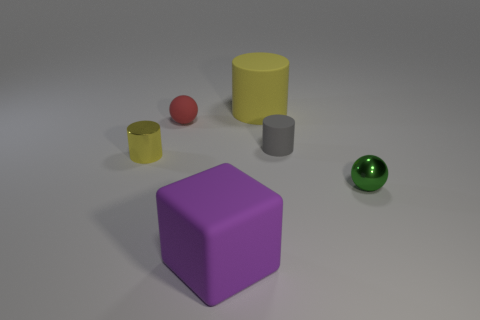How many other things are the same color as the metal cylinder?
Offer a very short reply. 1. Does the block have the same color as the big cylinder?
Your response must be concise. No. What number of yellow things have the same shape as the gray thing?
Provide a succinct answer. 2. Does the big purple thing have the same material as the red object?
Offer a terse response. Yes. What shape is the yellow metal thing behind the object that is in front of the shiny sphere?
Offer a very short reply. Cylinder. What number of purple things are to the left of the yellow cylinder that is behind the small rubber cylinder?
Provide a short and direct response. 1. What is the material of the tiny thing that is behind the green metal sphere and on the right side of the tiny red object?
Ensure brevity in your answer.  Rubber. There is another metallic object that is the same size as the yellow metal thing; what shape is it?
Ensure brevity in your answer.  Sphere. There is a tiny metal object in front of the yellow thing left of the yellow thing that is on the right side of the large purple rubber thing; what is its color?
Provide a succinct answer. Green. What number of objects are rubber cylinders that are left of the tiny gray thing or tiny green metallic objects?
Give a very brief answer. 2. 